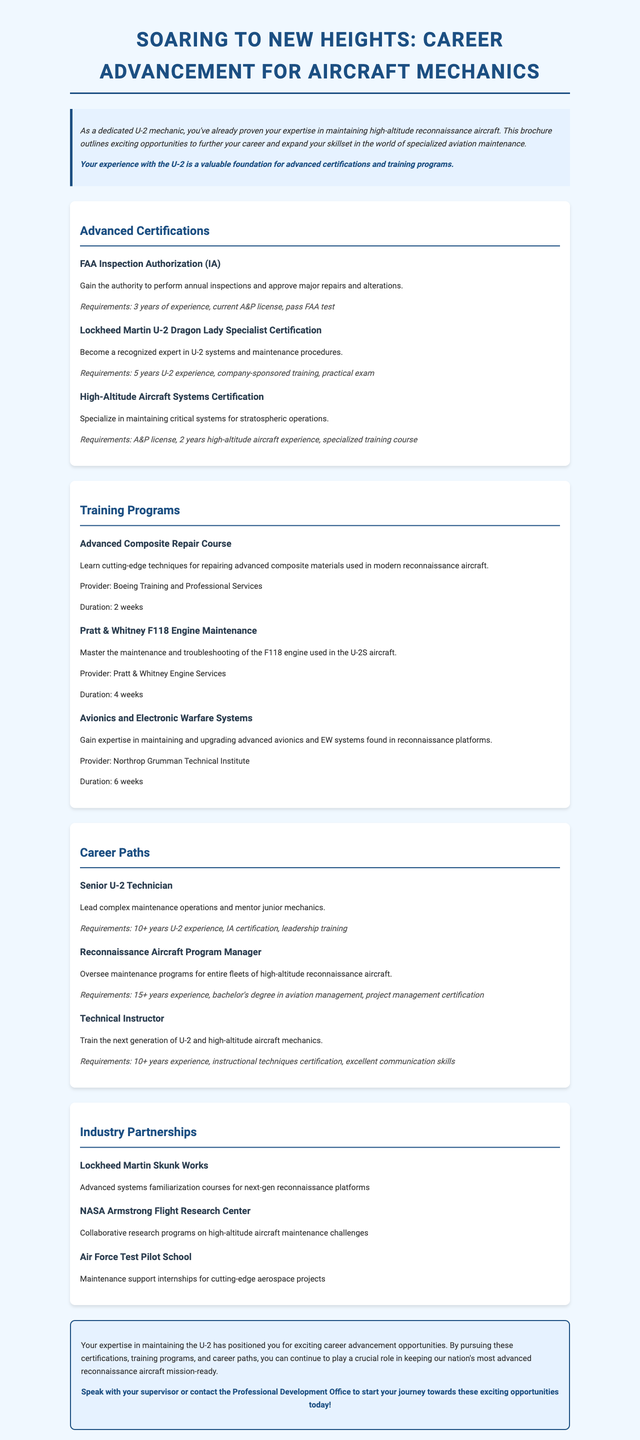What is the title of the brochure? The title of the brochure is displayed at the top of the document.
Answer: Soaring to New Heights: Career Advancement for Aircraft Mechanics How many years of experience are required for the FAA Inspection Authorization? The document specifies the requirements for various certifications.
Answer: 3 years Which program focuses on the F118 engine used in the U-2S aircraft? The document lists several training programs with their descriptions.
Answer: Pratt & Whitney F118 Engine Maintenance What is one of the opportunities presented by NASA Armstrong Flight Research Center? The brochure outlines various industry partnerships and their opportunities.
Answer: Collaborative research programs on high-altitude aircraft maintenance challenges What certification requires 10+ years of U-2 experience? The document describes career paths that include specific experience requirements.
Answer: Senior U-2 Technician How long is the Advanced Composite Repair Course? The duration of the training programs is mentioned in the document.
Answer: 2 weeks Which company provides the avionics and electronic warfare systems training? The document lists the providers of the different training programs.
Answer: Northrop Grumman Technical Institute What color theme is mainly used in the brochure? The design and visual elements of the brochure are described indirectly by the use of colors throughout the text.
Answer: Blue and white 